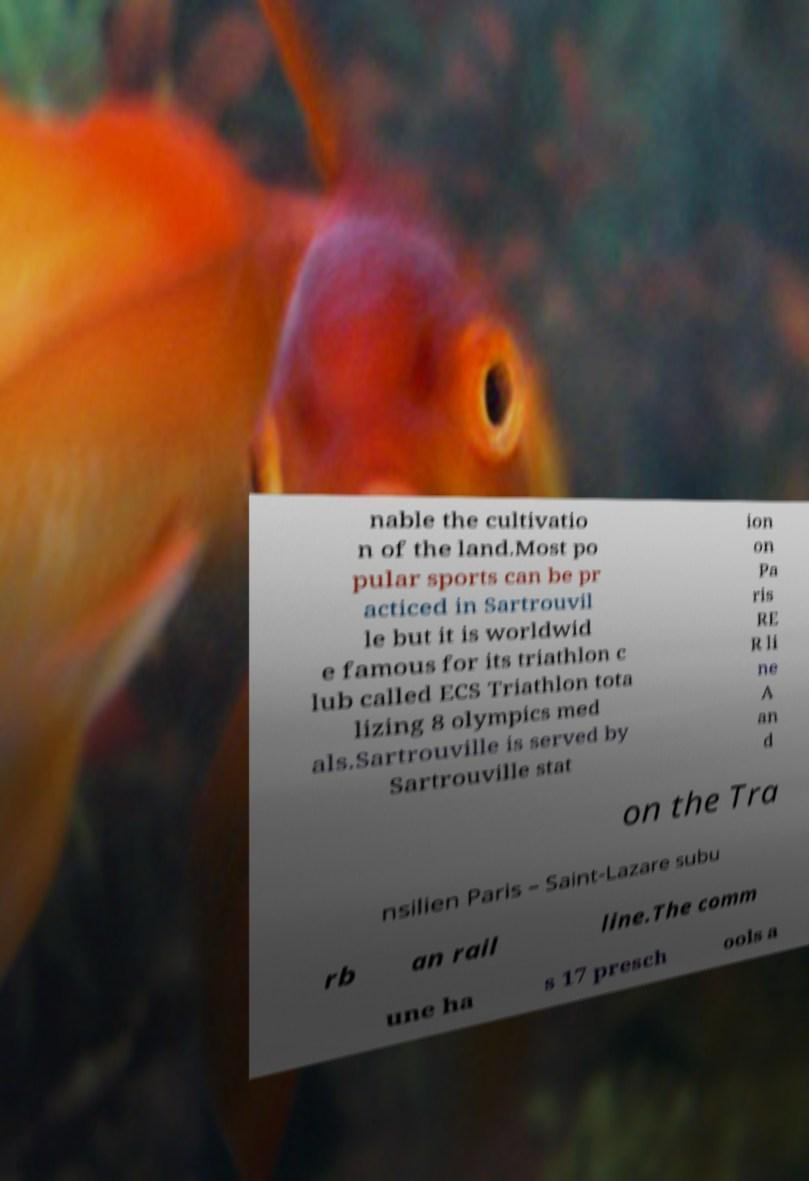What messages or text are displayed in this image? I need them in a readable, typed format. nable the cultivatio n of the land.Most po pular sports can be pr acticed in Sartrouvil le but it is worldwid e famous for its triathlon c lub called ECS Triathlon tota lizing 8 olympics med als.Sartrouville is served by Sartrouville stat ion on Pa ris RE R li ne A an d on the Tra nsilien Paris – Saint-Lazare subu rb an rail line.The comm une ha s 17 presch ools a 